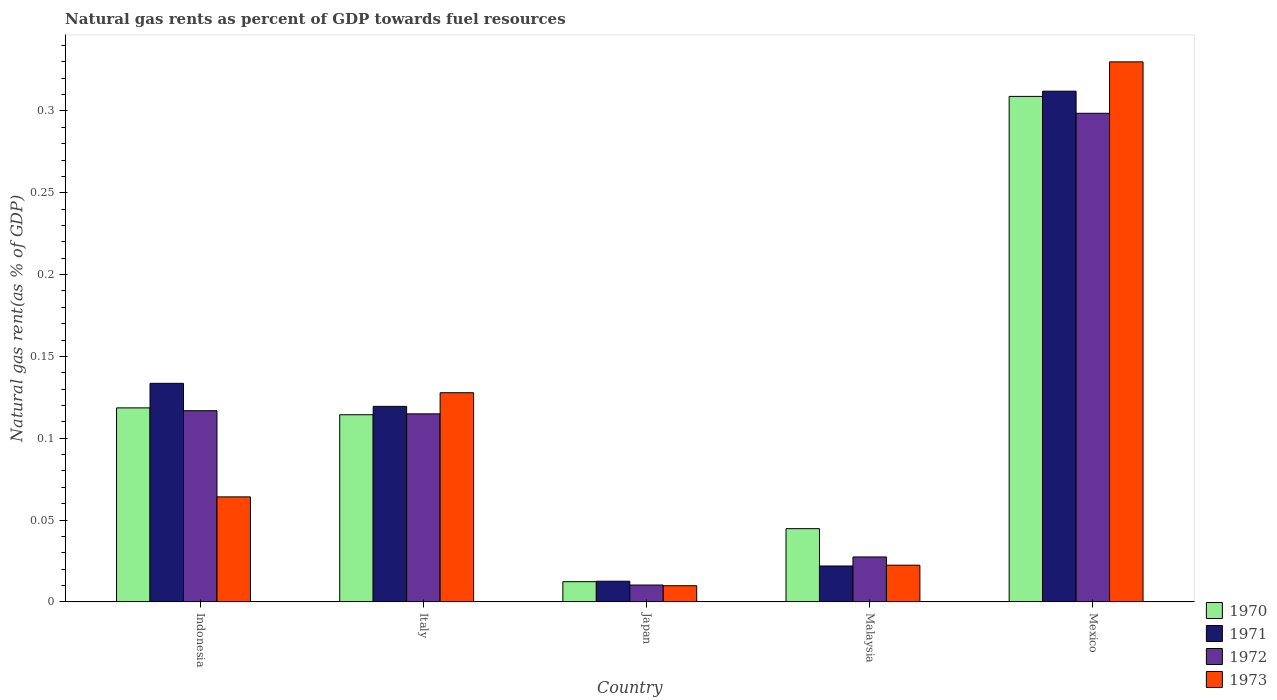How many groups of bars are there?
Your answer should be compact. 5. How many bars are there on the 3rd tick from the left?
Make the answer very short. 4. What is the label of the 3rd group of bars from the left?
Provide a succinct answer. Japan. In how many cases, is the number of bars for a given country not equal to the number of legend labels?
Make the answer very short. 0. What is the natural gas rent in 1973 in Malaysia?
Keep it short and to the point. 0.02. Across all countries, what is the maximum natural gas rent in 1970?
Ensure brevity in your answer.  0.31. Across all countries, what is the minimum natural gas rent in 1971?
Ensure brevity in your answer.  0.01. In which country was the natural gas rent in 1973 minimum?
Your response must be concise. Japan. What is the total natural gas rent in 1970 in the graph?
Your response must be concise. 0.6. What is the difference between the natural gas rent in 1970 in Indonesia and that in Mexico?
Offer a terse response. -0.19. What is the difference between the natural gas rent in 1970 in Mexico and the natural gas rent in 1971 in Indonesia?
Provide a succinct answer. 0.18. What is the average natural gas rent in 1973 per country?
Make the answer very short. 0.11. What is the difference between the natural gas rent of/in 1973 and natural gas rent of/in 1970 in Indonesia?
Provide a short and direct response. -0.05. What is the ratio of the natural gas rent in 1971 in Japan to that in Malaysia?
Give a very brief answer. 0.58. Is the natural gas rent in 1973 in Indonesia less than that in Italy?
Your response must be concise. Yes. Is the difference between the natural gas rent in 1973 in Indonesia and Mexico greater than the difference between the natural gas rent in 1970 in Indonesia and Mexico?
Keep it short and to the point. No. What is the difference between the highest and the second highest natural gas rent in 1973?
Offer a terse response. 0.27. What is the difference between the highest and the lowest natural gas rent in 1970?
Offer a terse response. 0.3. In how many countries, is the natural gas rent in 1973 greater than the average natural gas rent in 1973 taken over all countries?
Give a very brief answer. 2. Is the sum of the natural gas rent in 1973 in Indonesia and Italy greater than the maximum natural gas rent in 1972 across all countries?
Your answer should be compact. No. What does the 2nd bar from the right in Indonesia represents?
Offer a terse response. 1972. What is the difference between two consecutive major ticks on the Y-axis?
Offer a terse response. 0.05. Are the values on the major ticks of Y-axis written in scientific E-notation?
Offer a very short reply. No. What is the title of the graph?
Make the answer very short. Natural gas rents as percent of GDP towards fuel resources. What is the label or title of the Y-axis?
Your answer should be compact. Natural gas rent(as % of GDP). What is the Natural gas rent(as % of GDP) of 1970 in Indonesia?
Keep it short and to the point. 0.12. What is the Natural gas rent(as % of GDP) of 1971 in Indonesia?
Ensure brevity in your answer.  0.13. What is the Natural gas rent(as % of GDP) in 1972 in Indonesia?
Offer a very short reply. 0.12. What is the Natural gas rent(as % of GDP) in 1973 in Indonesia?
Keep it short and to the point. 0.06. What is the Natural gas rent(as % of GDP) of 1970 in Italy?
Provide a succinct answer. 0.11. What is the Natural gas rent(as % of GDP) of 1971 in Italy?
Provide a succinct answer. 0.12. What is the Natural gas rent(as % of GDP) of 1972 in Italy?
Give a very brief answer. 0.11. What is the Natural gas rent(as % of GDP) in 1973 in Italy?
Provide a short and direct response. 0.13. What is the Natural gas rent(as % of GDP) in 1970 in Japan?
Your answer should be compact. 0.01. What is the Natural gas rent(as % of GDP) in 1971 in Japan?
Your answer should be compact. 0.01. What is the Natural gas rent(as % of GDP) in 1972 in Japan?
Keep it short and to the point. 0.01. What is the Natural gas rent(as % of GDP) in 1973 in Japan?
Your answer should be very brief. 0.01. What is the Natural gas rent(as % of GDP) of 1970 in Malaysia?
Offer a terse response. 0.04. What is the Natural gas rent(as % of GDP) of 1971 in Malaysia?
Your answer should be very brief. 0.02. What is the Natural gas rent(as % of GDP) of 1972 in Malaysia?
Your answer should be very brief. 0.03. What is the Natural gas rent(as % of GDP) of 1973 in Malaysia?
Make the answer very short. 0.02. What is the Natural gas rent(as % of GDP) of 1970 in Mexico?
Your response must be concise. 0.31. What is the Natural gas rent(as % of GDP) of 1971 in Mexico?
Provide a short and direct response. 0.31. What is the Natural gas rent(as % of GDP) of 1972 in Mexico?
Provide a succinct answer. 0.3. What is the Natural gas rent(as % of GDP) of 1973 in Mexico?
Offer a terse response. 0.33. Across all countries, what is the maximum Natural gas rent(as % of GDP) of 1970?
Your answer should be compact. 0.31. Across all countries, what is the maximum Natural gas rent(as % of GDP) of 1971?
Your answer should be very brief. 0.31. Across all countries, what is the maximum Natural gas rent(as % of GDP) in 1972?
Offer a terse response. 0.3. Across all countries, what is the maximum Natural gas rent(as % of GDP) of 1973?
Give a very brief answer. 0.33. Across all countries, what is the minimum Natural gas rent(as % of GDP) of 1970?
Your answer should be very brief. 0.01. Across all countries, what is the minimum Natural gas rent(as % of GDP) of 1971?
Give a very brief answer. 0.01. Across all countries, what is the minimum Natural gas rent(as % of GDP) of 1972?
Give a very brief answer. 0.01. Across all countries, what is the minimum Natural gas rent(as % of GDP) of 1973?
Ensure brevity in your answer.  0.01. What is the total Natural gas rent(as % of GDP) in 1970 in the graph?
Provide a short and direct response. 0.6. What is the total Natural gas rent(as % of GDP) of 1971 in the graph?
Offer a very short reply. 0.6. What is the total Natural gas rent(as % of GDP) of 1972 in the graph?
Your response must be concise. 0.57. What is the total Natural gas rent(as % of GDP) of 1973 in the graph?
Ensure brevity in your answer.  0.55. What is the difference between the Natural gas rent(as % of GDP) of 1970 in Indonesia and that in Italy?
Keep it short and to the point. 0. What is the difference between the Natural gas rent(as % of GDP) in 1971 in Indonesia and that in Italy?
Offer a terse response. 0.01. What is the difference between the Natural gas rent(as % of GDP) of 1972 in Indonesia and that in Italy?
Offer a very short reply. 0. What is the difference between the Natural gas rent(as % of GDP) of 1973 in Indonesia and that in Italy?
Give a very brief answer. -0.06. What is the difference between the Natural gas rent(as % of GDP) of 1970 in Indonesia and that in Japan?
Offer a terse response. 0.11. What is the difference between the Natural gas rent(as % of GDP) of 1971 in Indonesia and that in Japan?
Keep it short and to the point. 0.12. What is the difference between the Natural gas rent(as % of GDP) of 1972 in Indonesia and that in Japan?
Your answer should be compact. 0.11. What is the difference between the Natural gas rent(as % of GDP) in 1973 in Indonesia and that in Japan?
Offer a very short reply. 0.05. What is the difference between the Natural gas rent(as % of GDP) of 1970 in Indonesia and that in Malaysia?
Ensure brevity in your answer.  0.07. What is the difference between the Natural gas rent(as % of GDP) of 1971 in Indonesia and that in Malaysia?
Offer a very short reply. 0.11. What is the difference between the Natural gas rent(as % of GDP) in 1972 in Indonesia and that in Malaysia?
Provide a short and direct response. 0.09. What is the difference between the Natural gas rent(as % of GDP) of 1973 in Indonesia and that in Malaysia?
Your answer should be compact. 0.04. What is the difference between the Natural gas rent(as % of GDP) of 1970 in Indonesia and that in Mexico?
Make the answer very short. -0.19. What is the difference between the Natural gas rent(as % of GDP) of 1971 in Indonesia and that in Mexico?
Offer a terse response. -0.18. What is the difference between the Natural gas rent(as % of GDP) in 1972 in Indonesia and that in Mexico?
Ensure brevity in your answer.  -0.18. What is the difference between the Natural gas rent(as % of GDP) of 1973 in Indonesia and that in Mexico?
Provide a succinct answer. -0.27. What is the difference between the Natural gas rent(as % of GDP) in 1970 in Italy and that in Japan?
Your answer should be very brief. 0.1. What is the difference between the Natural gas rent(as % of GDP) of 1971 in Italy and that in Japan?
Ensure brevity in your answer.  0.11. What is the difference between the Natural gas rent(as % of GDP) of 1972 in Italy and that in Japan?
Your answer should be compact. 0.1. What is the difference between the Natural gas rent(as % of GDP) of 1973 in Italy and that in Japan?
Ensure brevity in your answer.  0.12. What is the difference between the Natural gas rent(as % of GDP) of 1970 in Italy and that in Malaysia?
Keep it short and to the point. 0.07. What is the difference between the Natural gas rent(as % of GDP) in 1971 in Italy and that in Malaysia?
Your answer should be compact. 0.1. What is the difference between the Natural gas rent(as % of GDP) in 1972 in Italy and that in Malaysia?
Your answer should be compact. 0.09. What is the difference between the Natural gas rent(as % of GDP) in 1973 in Italy and that in Malaysia?
Make the answer very short. 0.11. What is the difference between the Natural gas rent(as % of GDP) of 1970 in Italy and that in Mexico?
Your response must be concise. -0.19. What is the difference between the Natural gas rent(as % of GDP) of 1971 in Italy and that in Mexico?
Ensure brevity in your answer.  -0.19. What is the difference between the Natural gas rent(as % of GDP) of 1972 in Italy and that in Mexico?
Offer a very short reply. -0.18. What is the difference between the Natural gas rent(as % of GDP) of 1973 in Italy and that in Mexico?
Provide a succinct answer. -0.2. What is the difference between the Natural gas rent(as % of GDP) in 1970 in Japan and that in Malaysia?
Offer a very short reply. -0.03. What is the difference between the Natural gas rent(as % of GDP) of 1971 in Japan and that in Malaysia?
Your answer should be compact. -0.01. What is the difference between the Natural gas rent(as % of GDP) of 1972 in Japan and that in Malaysia?
Your answer should be very brief. -0.02. What is the difference between the Natural gas rent(as % of GDP) in 1973 in Japan and that in Malaysia?
Give a very brief answer. -0.01. What is the difference between the Natural gas rent(as % of GDP) of 1970 in Japan and that in Mexico?
Provide a succinct answer. -0.3. What is the difference between the Natural gas rent(as % of GDP) in 1971 in Japan and that in Mexico?
Keep it short and to the point. -0.3. What is the difference between the Natural gas rent(as % of GDP) of 1972 in Japan and that in Mexico?
Your answer should be very brief. -0.29. What is the difference between the Natural gas rent(as % of GDP) of 1973 in Japan and that in Mexico?
Provide a succinct answer. -0.32. What is the difference between the Natural gas rent(as % of GDP) of 1970 in Malaysia and that in Mexico?
Your answer should be compact. -0.26. What is the difference between the Natural gas rent(as % of GDP) in 1971 in Malaysia and that in Mexico?
Ensure brevity in your answer.  -0.29. What is the difference between the Natural gas rent(as % of GDP) of 1972 in Malaysia and that in Mexico?
Your answer should be compact. -0.27. What is the difference between the Natural gas rent(as % of GDP) of 1973 in Malaysia and that in Mexico?
Your answer should be very brief. -0.31. What is the difference between the Natural gas rent(as % of GDP) in 1970 in Indonesia and the Natural gas rent(as % of GDP) in 1971 in Italy?
Provide a short and direct response. -0. What is the difference between the Natural gas rent(as % of GDP) in 1970 in Indonesia and the Natural gas rent(as % of GDP) in 1972 in Italy?
Give a very brief answer. 0. What is the difference between the Natural gas rent(as % of GDP) in 1970 in Indonesia and the Natural gas rent(as % of GDP) in 1973 in Italy?
Ensure brevity in your answer.  -0.01. What is the difference between the Natural gas rent(as % of GDP) of 1971 in Indonesia and the Natural gas rent(as % of GDP) of 1972 in Italy?
Offer a very short reply. 0.02. What is the difference between the Natural gas rent(as % of GDP) of 1971 in Indonesia and the Natural gas rent(as % of GDP) of 1973 in Italy?
Offer a very short reply. 0.01. What is the difference between the Natural gas rent(as % of GDP) in 1972 in Indonesia and the Natural gas rent(as % of GDP) in 1973 in Italy?
Keep it short and to the point. -0.01. What is the difference between the Natural gas rent(as % of GDP) of 1970 in Indonesia and the Natural gas rent(as % of GDP) of 1971 in Japan?
Your answer should be very brief. 0.11. What is the difference between the Natural gas rent(as % of GDP) of 1970 in Indonesia and the Natural gas rent(as % of GDP) of 1972 in Japan?
Keep it short and to the point. 0.11. What is the difference between the Natural gas rent(as % of GDP) in 1970 in Indonesia and the Natural gas rent(as % of GDP) in 1973 in Japan?
Your response must be concise. 0.11. What is the difference between the Natural gas rent(as % of GDP) in 1971 in Indonesia and the Natural gas rent(as % of GDP) in 1972 in Japan?
Offer a terse response. 0.12. What is the difference between the Natural gas rent(as % of GDP) of 1971 in Indonesia and the Natural gas rent(as % of GDP) of 1973 in Japan?
Give a very brief answer. 0.12. What is the difference between the Natural gas rent(as % of GDP) in 1972 in Indonesia and the Natural gas rent(as % of GDP) in 1973 in Japan?
Provide a short and direct response. 0.11. What is the difference between the Natural gas rent(as % of GDP) of 1970 in Indonesia and the Natural gas rent(as % of GDP) of 1971 in Malaysia?
Make the answer very short. 0.1. What is the difference between the Natural gas rent(as % of GDP) in 1970 in Indonesia and the Natural gas rent(as % of GDP) in 1972 in Malaysia?
Keep it short and to the point. 0.09. What is the difference between the Natural gas rent(as % of GDP) of 1970 in Indonesia and the Natural gas rent(as % of GDP) of 1973 in Malaysia?
Offer a very short reply. 0.1. What is the difference between the Natural gas rent(as % of GDP) of 1971 in Indonesia and the Natural gas rent(as % of GDP) of 1972 in Malaysia?
Provide a short and direct response. 0.11. What is the difference between the Natural gas rent(as % of GDP) of 1972 in Indonesia and the Natural gas rent(as % of GDP) of 1973 in Malaysia?
Give a very brief answer. 0.09. What is the difference between the Natural gas rent(as % of GDP) in 1970 in Indonesia and the Natural gas rent(as % of GDP) in 1971 in Mexico?
Provide a succinct answer. -0.19. What is the difference between the Natural gas rent(as % of GDP) of 1970 in Indonesia and the Natural gas rent(as % of GDP) of 1972 in Mexico?
Provide a succinct answer. -0.18. What is the difference between the Natural gas rent(as % of GDP) in 1970 in Indonesia and the Natural gas rent(as % of GDP) in 1973 in Mexico?
Offer a terse response. -0.21. What is the difference between the Natural gas rent(as % of GDP) of 1971 in Indonesia and the Natural gas rent(as % of GDP) of 1972 in Mexico?
Provide a succinct answer. -0.17. What is the difference between the Natural gas rent(as % of GDP) of 1971 in Indonesia and the Natural gas rent(as % of GDP) of 1973 in Mexico?
Offer a terse response. -0.2. What is the difference between the Natural gas rent(as % of GDP) in 1972 in Indonesia and the Natural gas rent(as % of GDP) in 1973 in Mexico?
Your response must be concise. -0.21. What is the difference between the Natural gas rent(as % of GDP) in 1970 in Italy and the Natural gas rent(as % of GDP) in 1971 in Japan?
Provide a succinct answer. 0.1. What is the difference between the Natural gas rent(as % of GDP) of 1970 in Italy and the Natural gas rent(as % of GDP) of 1972 in Japan?
Provide a succinct answer. 0.1. What is the difference between the Natural gas rent(as % of GDP) of 1970 in Italy and the Natural gas rent(as % of GDP) of 1973 in Japan?
Your answer should be very brief. 0.1. What is the difference between the Natural gas rent(as % of GDP) in 1971 in Italy and the Natural gas rent(as % of GDP) in 1972 in Japan?
Provide a short and direct response. 0.11. What is the difference between the Natural gas rent(as % of GDP) of 1971 in Italy and the Natural gas rent(as % of GDP) of 1973 in Japan?
Provide a short and direct response. 0.11. What is the difference between the Natural gas rent(as % of GDP) of 1972 in Italy and the Natural gas rent(as % of GDP) of 1973 in Japan?
Your response must be concise. 0.1. What is the difference between the Natural gas rent(as % of GDP) in 1970 in Italy and the Natural gas rent(as % of GDP) in 1971 in Malaysia?
Your response must be concise. 0.09. What is the difference between the Natural gas rent(as % of GDP) of 1970 in Italy and the Natural gas rent(as % of GDP) of 1972 in Malaysia?
Your answer should be compact. 0.09. What is the difference between the Natural gas rent(as % of GDP) in 1970 in Italy and the Natural gas rent(as % of GDP) in 1973 in Malaysia?
Keep it short and to the point. 0.09. What is the difference between the Natural gas rent(as % of GDP) in 1971 in Italy and the Natural gas rent(as % of GDP) in 1972 in Malaysia?
Your answer should be very brief. 0.09. What is the difference between the Natural gas rent(as % of GDP) in 1971 in Italy and the Natural gas rent(as % of GDP) in 1973 in Malaysia?
Provide a succinct answer. 0.1. What is the difference between the Natural gas rent(as % of GDP) in 1972 in Italy and the Natural gas rent(as % of GDP) in 1973 in Malaysia?
Your answer should be compact. 0.09. What is the difference between the Natural gas rent(as % of GDP) of 1970 in Italy and the Natural gas rent(as % of GDP) of 1971 in Mexico?
Make the answer very short. -0.2. What is the difference between the Natural gas rent(as % of GDP) in 1970 in Italy and the Natural gas rent(as % of GDP) in 1972 in Mexico?
Make the answer very short. -0.18. What is the difference between the Natural gas rent(as % of GDP) of 1970 in Italy and the Natural gas rent(as % of GDP) of 1973 in Mexico?
Provide a short and direct response. -0.22. What is the difference between the Natural gas rent(as % of GDP) in 1971 in Italy and the Natural gas rent(as % of GDP) in 1972 in Mexico?
Provide a succinct answer. -0.18. What is the difference between the Natural gas rent(as % of GDP) of 1971 in Italy and the Natural gas rent(as % of GDP) of 1973 in Mexico?
Give a very brief answer. -0.21. What is the difference between the Natural gas rent(as % of GDP) of 1972 in Italy and the Natural gas rent(as % of GDP) of 1973 in Mexico?
Make the answer very short. -0.22. What is the difference between the Natural gas rent(as % of GDP) in 1970 in Japan and the Natural gas rent(as % of GDP) in 1971 in Malaysia?
Your response must be concise. -0.01. What is the difference between the Natural gas rent(as % of GDP) in 1970 in Japan and the Natural gas rent(as % of GDP) in 1972 in Malaysia?
Ensure brevity in your answer.  -0.02. What is the difference between the Natural gas rent(as % of GDP) of 1970 in Japan and the Natural gas rent(as % of GDP) of 1973 in Malaysia?
Ensure brevity in your answer.  -0.01. What is the difference between the Natural gas rent(as % of GDP) of 1971 in Japan and the Natural gas rent(as % of GDP) of 1972 in Malaysia?
Give a very brief answer. -0.01. What is the difference between the Natural gas rent(as % of GDP) in 1971 in Japan and the Natural gas rent(as % of GDP) in 1973 in Malaysia?
Your answer should be very brief. -0.01. What is the difference between the Natural gas rent(as % of GDP) of 1972 in Japan and the Natural gas rent(as % of GDP) of 1973 in Malaysia?
Ensure brevity in your answer.  -0.01. What is the difference between the Natural gas rent(as % of GDP) of 1970 in Japan and the Natural gas rent(as % of GDP) of 1971 in Mexico?
Your answer should be very brief. -0.3. What is the difference between the Natural gas rent(as % of GDP) of 1970 in Japan and the Natural gas rent(as % of GDP) of 1972 in Mexico?
Keep it short and to the point. -0.29. What is the difference between the Natural gas rent(as % of GDP) of 1970 in Japan and the Natural gas rent(as % of GDP) of 1973 in Mexico?
Your answer should be compact. -0.32. What is the difference between the Natural gas rent(as % of GDP) of 1971 in Japan and the Natural gas rent(as % of GDP) of 1972 in Mexico?
Your response must be concise. -0.29. What is the difference between the Natural gas rent(as % of GDP) of 1971 in Japan and the Natural gas rent(as % of GDP) of 1973 in Mexico?
Offer a terse response. -0.32. What is the difference between the Natural gas rent(as % of GDP) in 1972 in Japan and the Natural gas rent(as % of GDP) in 1973 in Mexico?
Ensure brevity in your answer.  -0.32. What is the difference between the Natural gas rent(as % of GDP) in 1970 in Malaysia and the Natural gas rent(as % of GDP) in 1971 in Mexico?
Provide a short and direct response. -0.27. What is the difference between the Natural gas rent(as % of GDP) in 1970 in Malaysia and the Natural gas rent(as % of GDP) in 1972 in Mexico?
Make the answer very short. -0.25. What is the difference between the Natural gas rent(as % of GDP) in 1970 in Malaysia and the Natural gas rent(as % of GDP) in 1973 in Mexico?
Provide a succinct answer. -0.29. What is the difference between the Natural gas rent(as % of GDP) in 1971 in Malaysia and the Natural gas rent(as % of GDP) in 1972 in Mexico?
Ensure brevity in your answer.  -0.28. What is the difference between the Natural gas rent(as % of GDP) of 1971 in Malaysia and the Natural gas rent(as % of GDP) of 1973 in Mexico?
Offer a very short reply. -0.31. What is the difference between the Natural gas rent(as % of GDP) of 1972 in Malaysia and the Natural gas rent(as % of GDP) of 1973 in Mexico?
Provide a short and direct response. -0.3. What is the average Natural gas rent(as % of GDP) of 1970 per country?
Provide a succinct answer. 0.12. What is the average Natural gas rent(as % of GDP) of 1971 per country?
Offer a very short reply. 0.12. What is the average Natural gas rent(as % of GDP) of 1972 per country?
Keep it short and to the point. 0.11. What is the average Natural gas rent(as % of GDP) of 1973 per country?
Provide a short and direct response. 0.11. What is the difference between the Natural gas rent(as % of GDP) in 1970 and Natural gas rent(as % of GDP) in 1971 in Indonesia?
Ensure brevity in your answer.  -0.01. What is the difference between the Natural gas rent(as % of GDP) of 1970 and Natural gas rent(as % of GDP) of 1972 in Indonesia?
Keep it short and to the point. 0. What is the difference between the Natural gas rent(as % of GDP) in 1970 and Natural gas rent(as % of GDP) in 1973 in Indonesia?
Keep it short and to the point. 0.05. What is the difference between the Natural gas rent(as % of GDP) in 1971 and Natural gas rent(as % of GDP) in 1972 in Indonesia?
Give a very brief answer. 0.02. What is the difference between the Natural gas rent(as % of GDP) in 1971 and Natural gas rent(as % of GDP) in 1973 in Indonesia?
Your response must be concise. 0.07. What is the difference between the Natural gas rent(as % of GDP) in 1972 and Natural gas rent(as % of GDP) in 1973 in Indonesia?
Keep it short and to the point. 0.05. What is the difference between the Natural gas rent(as % of GDP) in 1970 and Natural gas rent(as % of GDP) in 1971 in Italy?
Ensure brevity in your answer.  -0.01. What is the difference between the Natural gas rent(as % of GDP) in 1970 and Natural gas rent(as % of GDP) in 1972 in Italy?
Offer a terse response. -0. What is the difference between the Natural gas rent(as % of GDP) of 1970 and Natural gas rent(as % of GDP) of 1973 in Italy?
Your answer should be compact. -0.01. What is the difference between the Natural gas rent(as % of GDP) in 1971 and Natural gas rent(as % of GDP) in 1972 in Italy?
Your answer should be very brief. 0. What is the difference between the Natural gas rent(as % of GDP) in 1971 and Natural gas rent(as % of GDP) in 1973 in Italy?
Give a very brief answer. -0.01. What is the difference between the Natural gas rent(as % of GDP) in 1972 and Natural gas rent(as % of GDP) in 1973 in Italy?
Your answer should be very brief. -0.01. What is the difference between the Natural gas rent(as % of GDP) of 1970 and Natural gas rent(as % of GDP) of 1971 in Japan?
Your response must be concise. -0. What is the difference between the Natural gas rent(as % of GDP) of 1970 and Natural gas rent(as % of GDP) of 1972 in Japan?
Your answer should be very brief. 0. What is the difference between the Natural gas rent(as % of GDP) in 1970 and Natural gas rent(as % of GDP) in 1973 in Japan?
Your answer should be compact. 0. What is the difference between the Natural gas rent(as % of GDP) of 1971 and Natural gas rent(as % of GDP) of 1972 in Japan?
Make the answer very short. 0. What is the difference between the Natural gas rent(as % of GDP) of 1971 and Natural gas rent(as % of GDP) of 1973 in Japan?
Ensure brevity in your answer.  0. What is the difference between the Natural gas rent(as % of GDP) in 1970 and Natural gas rent(as % of GDP) in 1971 in Malaysia?
Your answer should be compact. 0.02. What is the difference between the Natural gas rent(as % of GDP) in 1970 and Natural gas rent(as % of GDP) in 1972 in Malaysia?
Ensure brevity in your answer.  0.02. What is the difference between the Natural gas rent(as % of GDP) in 1970 and Natural gas rent(as % of GDP) in 1973 in Malaysia?
Provide a succinct answer. 0.02. What is the difference between the Natural gas rent(as % of GDP) of 1971 and Natural gas rent(as % of GDP) of 1972 in Malaysia?
Your response must be concise. -0.01. What is the difference between the Natural gas rent(as % of GDP) in 1971 and Natural gas rent(as % of GDP) in 1973 in Malaysia?
Provide a succinct answer. -0. What is the difference between the Natural gas rent(as % of GDP) of 1972 and Natural gas rent(as % of GDP) of 1973 in Malaysia?
Offer a terse response. 0.01. What is the difference between the Natural gas rent(as % of GDP) of 1970 and Natural gas rent(as % of GDP) of 1971 in Mexico?
Make the answer very short. -0. What is the difference between the Natural gas rent(as % of GDP) in 1970 and Natural gas rent(as % of GDP) in 1972 in Mexico?
Your response must be concise. 0.01. What is the difference between the Natural gas rent(as % of GDP) in 1970 and Natural gas rent(as % of GDP) in 1973 in Mexico?
Give a very brief answer. -0.02. What is the difference between the Natural gas rent(as % of GDP) of 1971 and Natural gas rent(as % of GDP) of 1972 in Mexico?
Keep it short and to the point. 0.01. What is the difference between the Natural gas rent(as % of GDP) of 1971 and Natural gas rent(as % of GDP) of 1973 in Mexico?
Give a very brief answer. -0.02. What is the difference between the Natural gas rent(as % of GDP) of 1972 and Natural gas rent(as % of GDP) of 1973 in Mexico?
Your answer should be very brief. -0.03. What is the ratio of the Natural gas rent(as % of GDP) of 1970 in Indonesia to that in Italy?
Offer a terse response. 1.04. What is the ratio of the Natural gas rent(as % of GDP) in 1971 in Indonesia to that in Italy?
Offer a very short reply. 1.12. What is the ratio of the Natural gas rent(as % of GDP) in 1972 in Indonesia to that in Italy?
Give a very brief answer. 1.02. What is the ratio of the Natural gas rent(as % of GDP) in 1973 in Indonesia to that in Italy?
Your answer should be compact. 0.5. What is the ratio of the Natural gas rent(as % of GDP) in 1970 in Indonesia to that in Japan?
Offer a terse response. 9.61. What is the ratio of the Natural gas rent(as % of GDP) of 1971 in Indonesia to that in Japan?
Offer a terse response. 10.58. What is the ratio of the Natural gas rent(as % of GDP) of 1972 in Indonesia to that in Japan?
Your answer should be very brief. 11.34. What is the ratio of the Natural gas rent(as % of GDP) of 1973 in Indonesia to that in Japan?
Keep it short and to the point. 6.5. What is the ratio of the Natural gas rent(as % of GDP) of 1970 in Indonesia to that in Malaysia?
Provide a succinct answer. 2.65. What is the ratio of the Natural gas rent(as % of GDP) in 1971 in Indonesia to that in Malaysia?
Provide a short and direct response. 6.09. What is the ratio of the Natural gas rent(as % of GDP) of 1972 in Indonesia to that in Malaysia?
Your answer should be compact. 4.26. What is the ratio of the Natural gas rent(as % of GDP) in 1973 in Indonesia to that in Malaysia?
Your answer should be compact. 2.86. What is the ratio of the Natural gas rent(as % of GDP) in 1970 in Indonesia to that in Mexico?
Provide a succinct answer. 0.38. What is the ratio of the Natural gas rent(as % of GDP) of 1971 in Indonesia to that in Mexico?
Make the answer very short. 0.43. What is the ratio of the Natural gas rent(as % of GDP) of 1972 in Indonesia to that in Mexico?
Keep it short and to the point. 0.39. What is the ratio of the Natural gas rent(as % of GDP) of 1973 in Indonesia to that in Mexico?
Offer a terse response. 0.19. What is the ratio of the Natural gas rent(as % of GDP) of 1970 in Italy to that in Japan?
Provide a succinct answer. 9.27. What is the ratio of the Natural gas rent(as % of GDP) in 1971 in Italy to that in Japan?
Your response must be concise. 9.46. What is the ratio of the Natural gas rent(as % of GDP) in 1972 in Italy to that in Japan?
Your answer should be compact. 11.16. What is the ratio of the Natural gas rent(as % of GDP) of 1973 in Italy to that in Japan?
Your answer should be compact. 12.96. What is the ratio of the Natural gas rent(as % of GDP) in 1970 in Italy to that in Malaysia?
Your answer should be very brief. 2.56. What is the ratio of the Natural gas rent(as % of GDP) in 1971 in Italy to that in Malaysia?
Make the answer very short. 5.45. What is the ratio of the Natural gas rent(as % of GDP) in 1972 in Italy to that in Malaysia?
Provide a short and direct response. 4.19. What is the ratio of the Natural gas rent(as % of GDP) of 1973 in Italy to that in Malaysia?
Keep it short and to the point. 5.7. What is the ratio of the Natural gas rent(as % of GDP) of 1970 in Italy to that in Mexico?
Ensure brevity in your answer.  0.37. What is the ratio of the Natural gas rent(as % of GDP) of 1971 in Italy to that in Mexico?
Your answer should be compact. 0.38. What is the ratio of the Natural gas rent(as % of GDP) of 1972 in Italy to that in Mexico?
Provide a short and direct response. 0.38. What is the ratio of the Natural gas rent(as % of GDP) of 1973 in Italy to that in Mexico?
Give a very brief answer. 0.39. What is the ratio of the Natural gas rent(as % of GDP) in 1970 in Japan to that in Malaysia?
Your answer should be compact. 0.28. What is the ratio of the Natural gas rent(as % of GDP) of 1971 in Japan to that in Malaysia?
Your answer should be very brief. 0.58. What is the ratio of the Natural gas rent(as % of GDP) in 1972 in Japan to that in Malaysia?
Offer a terse response. 0.38. What is the ratio of the Natural gas rent(as % of GDP) of 1973 in Japan to that in Malaysia?
Your response must be concise. 0.44. What is the ratio of the Natural gas rent(as % of GDP) of 1970 in Japan to that in Mexico?
Make the answer very short. 0.04. What is the ratio of the Natural gas rent(as % of GDP) of 1971 in Japan to that in Mexico?
Provide a succinct answer. 0.04. What is the ratio of the Natural gas rent(as % of GDP) of 1972 in Japan to that in Mexico?
Your answer should be very brief. 0.03. What is the ratio of the Natural gas rent(as % of GDP) in 1973 in Japan to that in Mexico?
Make the answer very short. 0.03. What is the ratio of the Natural gas rent(as % of GDP) of 1970 in Malaysia to that in Mexico?
Offer a very short reply. 0.14. What is the ratio of the Natural gas rent(as % of GDP) of 1971 in Malaysia to that in Mexico?
Provide a short and direct response. 0.07. What is the ratio of the Natural gas rent(as % of GDP) in 1972 in Malaysia to that in Mexico?
Provide a succinct answer. 0.09. What is the ratio of the Natural gas rent(as % of GDP) of 1973 in Malaysia to that in Mexico?
Make the answer very short. 0.07. What is the difference between the highest and the second highest Natural gas rent(as % of GDP) in 1970?
Provide a succinct answer. 0.19. What is the difference between the highest and the second highest Natural gas rent(as % of GDP) in 1971?
Give a very brief answer. 0.18. What is the difference between the highest and the second highest Natural gas rent(as % of GDP) of 1972?
Provide a succinct answer. 0.18. What is the difference between the highest and the second highest Natural gas rent(as % of GDP) of 1973?
Keep it short and to the point. 0.2. What is the difference between the highest and the lowest Natural gas rent(as % of GDP) in 1970?
Offer a terse response. 0.3. What is the difference between the highest and the lowest Natural gas rent(as % of GDP) in 1971?
Provide a short and direct response. 0.3. What is the difference between the highest and the lowest Natural gas rent(as % of GDP) of 1972?
Your response must be concise. 0.29. What is the difference between the highest and the lowest Natural gas rent(as % of GDP) of 1973?
Your answer should be compact. 0.32. 